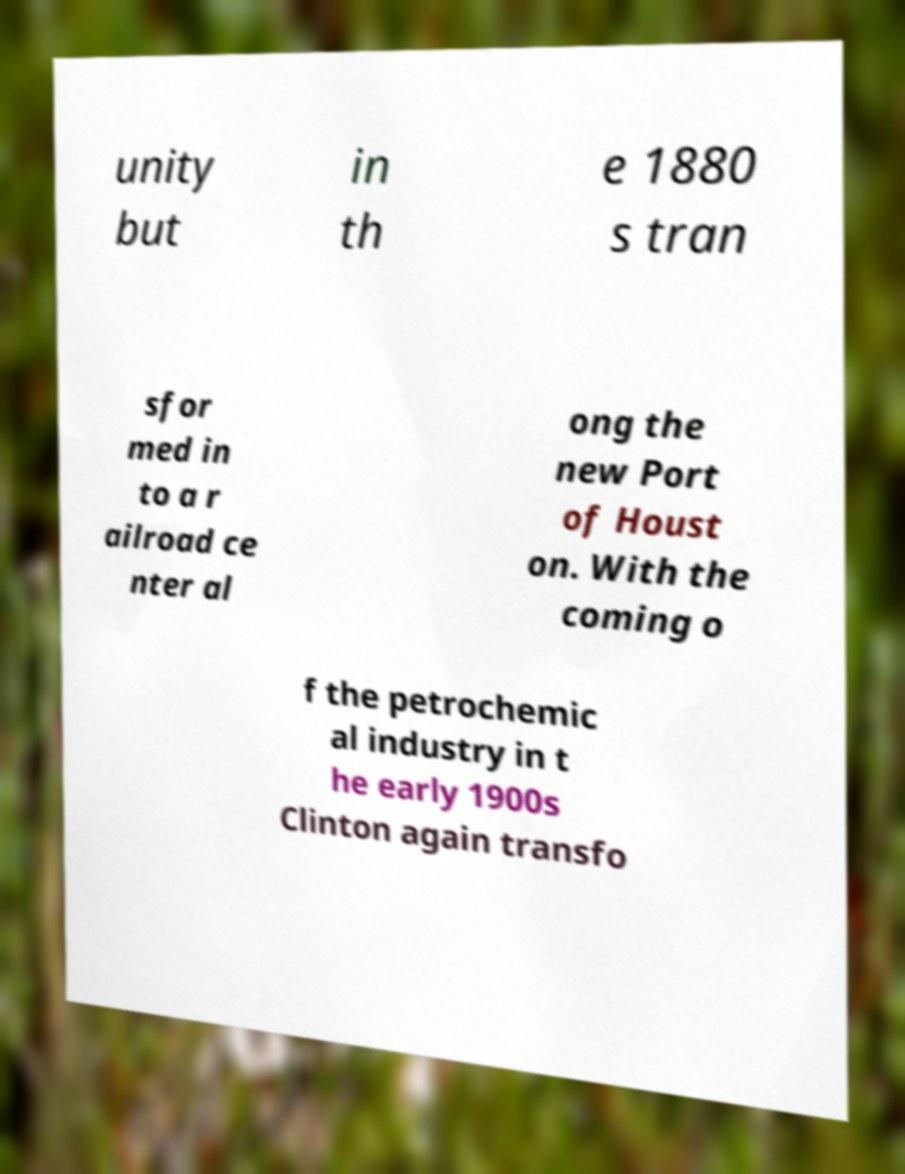For documentation purposes, I need the text within this image transcribed. Could you provide that? unity but in th e 1880 s tran sfor med in to a r ailroad ce nter al ong the new Port of Houst on. With the coming o f the petrochemic al industry in t he early 1900s Clinton again transfo 